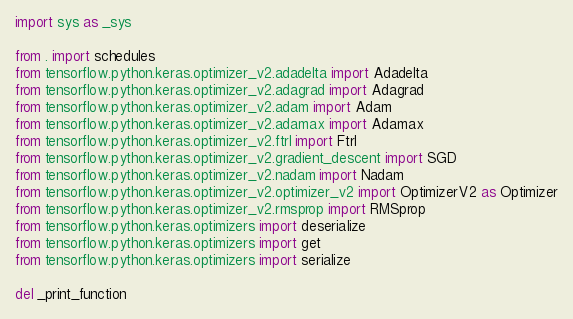Convert code to text. <code><loc_0><loc_0><loc_500><loc_500><_Python_>import sys as _sys

from . import schedules
from tensorflow.python.keras.optimizer_v2.adadelta import Adadelta
from tensorflow.python.keras.optimizer_v2.adagrad import Adagrad
from tensorflow.python.keras.optimizer_v2.adam import Adam
from tensorflow.python.keras.optimizer_v2.adamax import Adamax
from tensorflow.python.keras.optimizer_v2.ftrl import Ftrl
from tensorflow.python.keras.optimizer_v2.gradient_descent import SGD
from tensorflow.python.keras.optimizer_v2.nadam import Nadam
from tensorflow.python.keras.optimizer_v2.optimizer_v2 import OptimizerV2 as Optimizer
from tensorflow.python.keras.optimizer_v2.rmsprop import RMSprop
from tensorflow.python.keras.optimizers import deserialize
from tensorflow.python.keras.optimizers import get
from tensorflow.python.keras.optimizers import serialize

del _print_function
</code> 